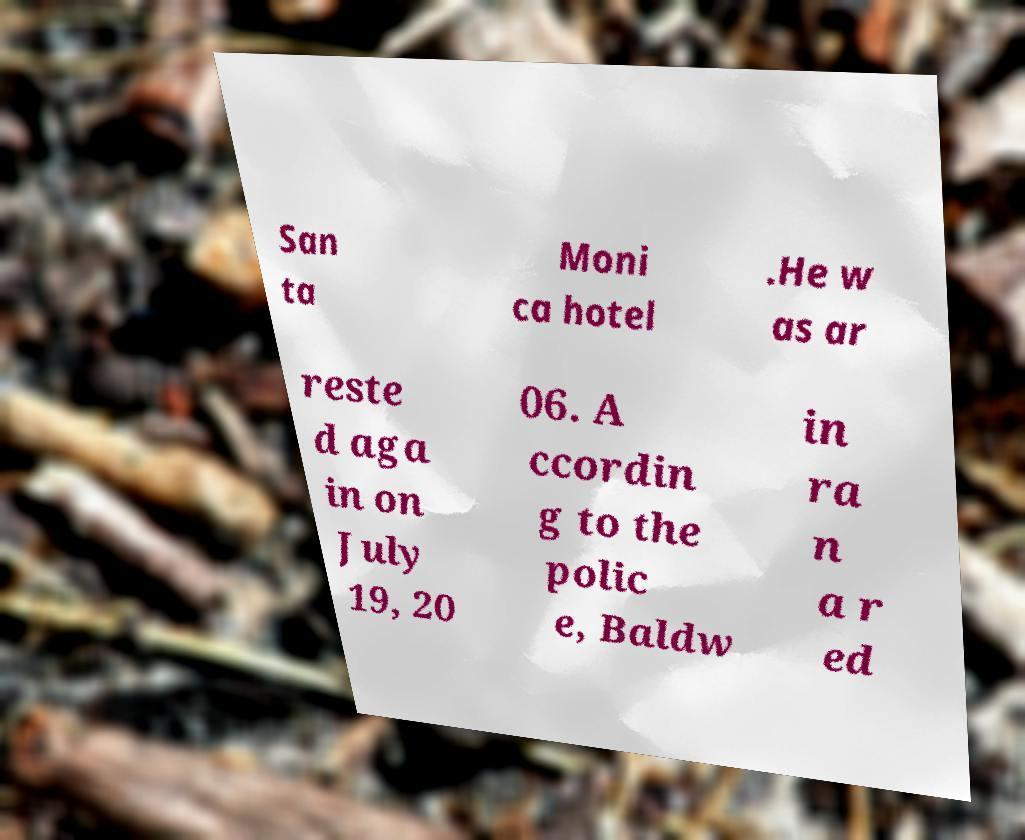There's text embedded in this image that I need extracted. Can you transcribe it verbatim? San ta Moni ca hotel .He w as ar reste d aga in on July 19, 20 06. A ccordin g to the polic e, Baldw in ra n a r ed 